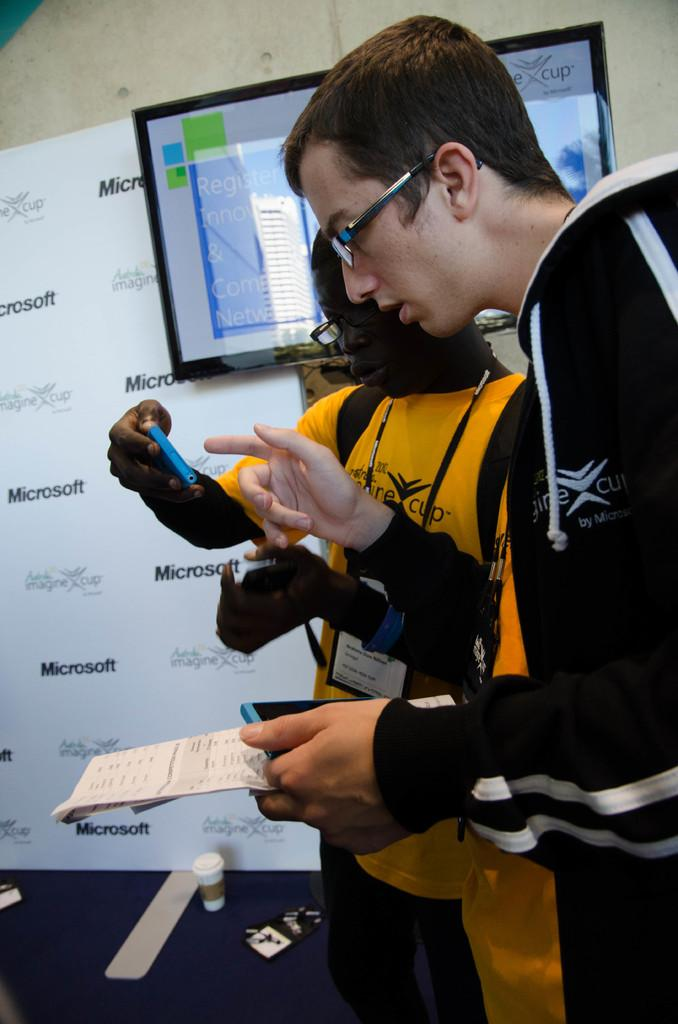How many people are in the image? There are two people standing in the image. What are the people wearing? Both people are wearing glasses. What are the people holding in their hands? Both people are holding mobile phones. What can be seen in the background of the image? There is a banner, a wall, and a screen in the background of the image. What object is on the floor in the image? There is a glass object on the floor. How many toes can be seen on the people in the image? There is no visible toes on the people in the image, as they are wearing shoes or standing on a surface that covers their feet. 